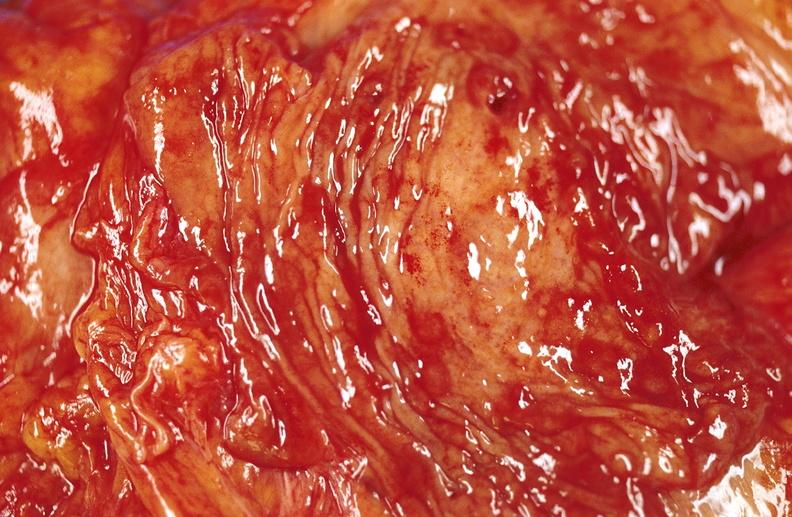s stillborn macerated present?
Answer the question using a single word or phrase. No 